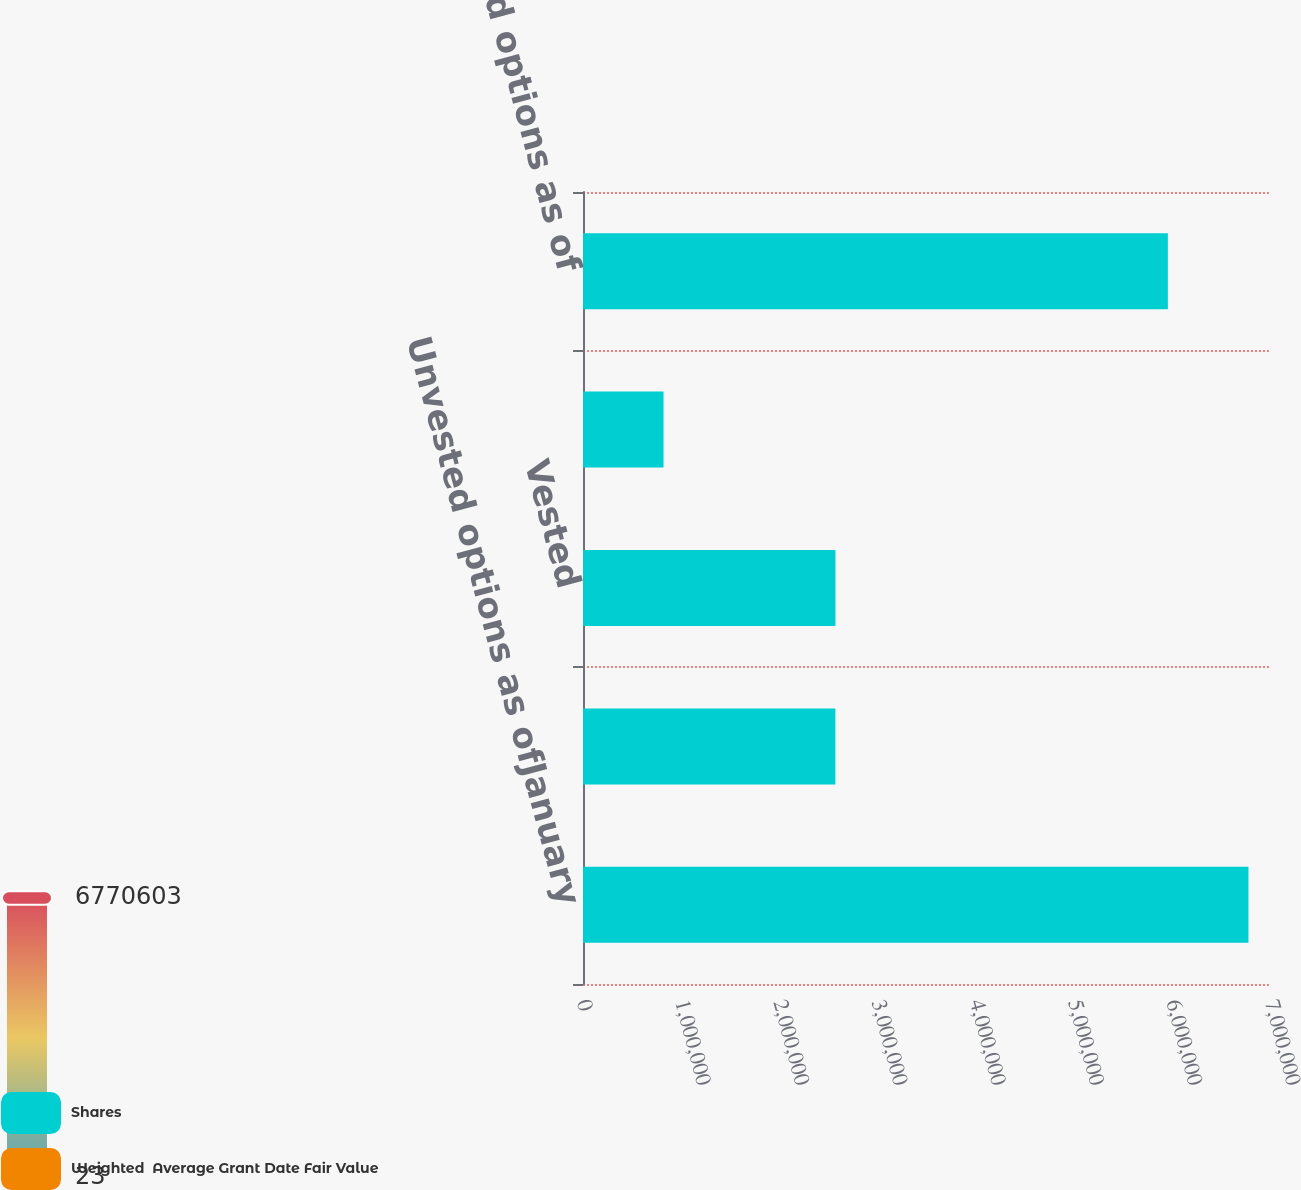Convert chart to OTSL. <chart><loc_0><loc_0><loc_500><loc_500><stacked_bar_chart><ecel><fcel>Unvested options as ofJanuary<fcel>Granted<fcel>Vested<fcel>Cancelled<fcel>Unvested options as of<nl><fcel>Shares<fcel>6.7706e+06<fcel>2.56765e+06<fcel>2.56838e+06<fcel>819265<fcel>5.95061e+06<nl><fcel>Weighted  Average Grant Date Fair Value<fcel>24.16<fcel>28.19<fcel>22.6<fcel>25.87<fcel>26.34<nl></chart> 